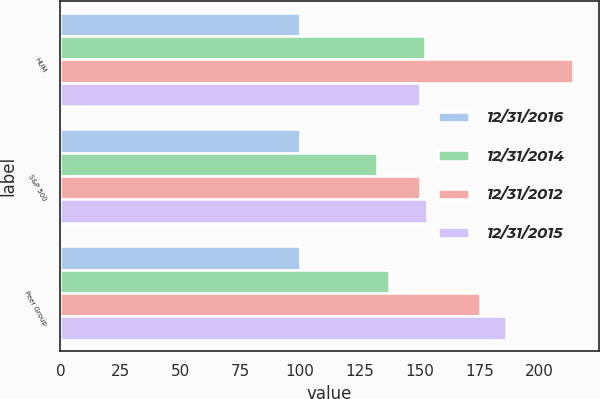Convert chart. <chart><loc_0><loc_0><loc_500><loc_500><stacked_bar_chart><ecel><fcel>HUM<fcel>S&P 500<fcel>Peer Group<nl><fcel>12/31/2016<fcel>100<fcel>100<fcel>100<nl><fcel>12/31/2014<fcel>152<fcel>132<fcel>137<nl><fcel>12/31/2012<fcel>214<fcel>150<fcel>175<nl><fcel>12/31/2015<fcel>150<fcel>153<fcel>186<nl></chart> 